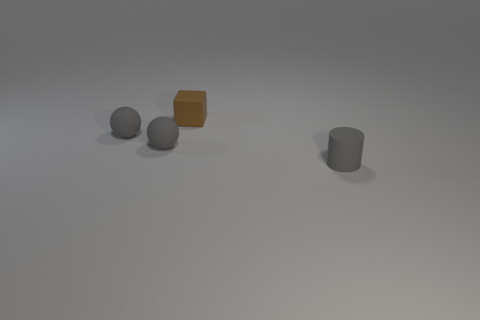There is a rubber thing to the right of the tiny brown rubber cube; what number of brown things are left of it? To the left of the small brown rubber cube, there is one larger brown object, which is cylindrical in shape. So, the total count of brown objects to the left of the brown cube is one. 